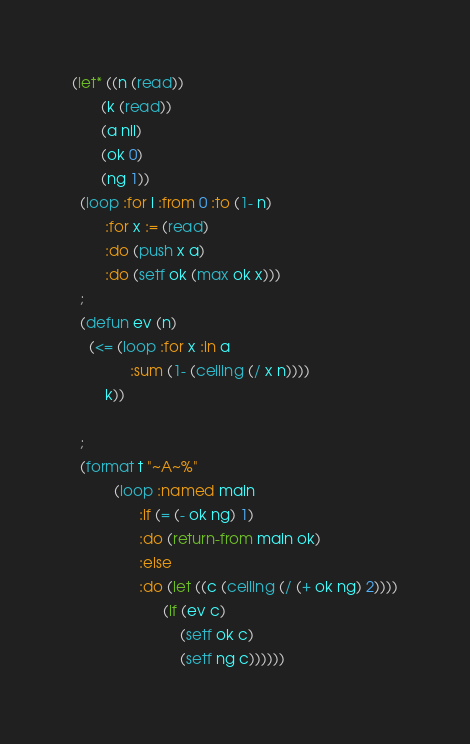Convert code to text. <code><loc_0><loc_0><loc_500><loc_500><_Lisp_>(let* ((n (read))
       (k (read))
       (a nil)
       (ok 0)
       (ng 1))
  (loop :for i :from 0 :to (1- n)
        :for x := (read)
        :do (push x a)
        :do (setf ok (max ok x)))
  ;
  (defun ev (n)
    (<= (loop :for x :in a
              :sum (1- (ceiling (/ x n))))
        k))
    
  ;
  (format t "~A~%"
          (loop :named main
                :if (= (- ok ng) 1)
                :do (return-from main ok)
                :else
                :do (let ((c (ceiling (/ (+ ok ng) 2))))
                      (if (ev c)
                          (setf ok c)
                          (setf ng c))))))
</code> 